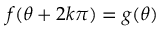Convert formula to latex. <formula><loc_0><loc_0><loc_500><loc_500>f ( \theta + 2 k \pi ) = g ( \theta )</formula> 